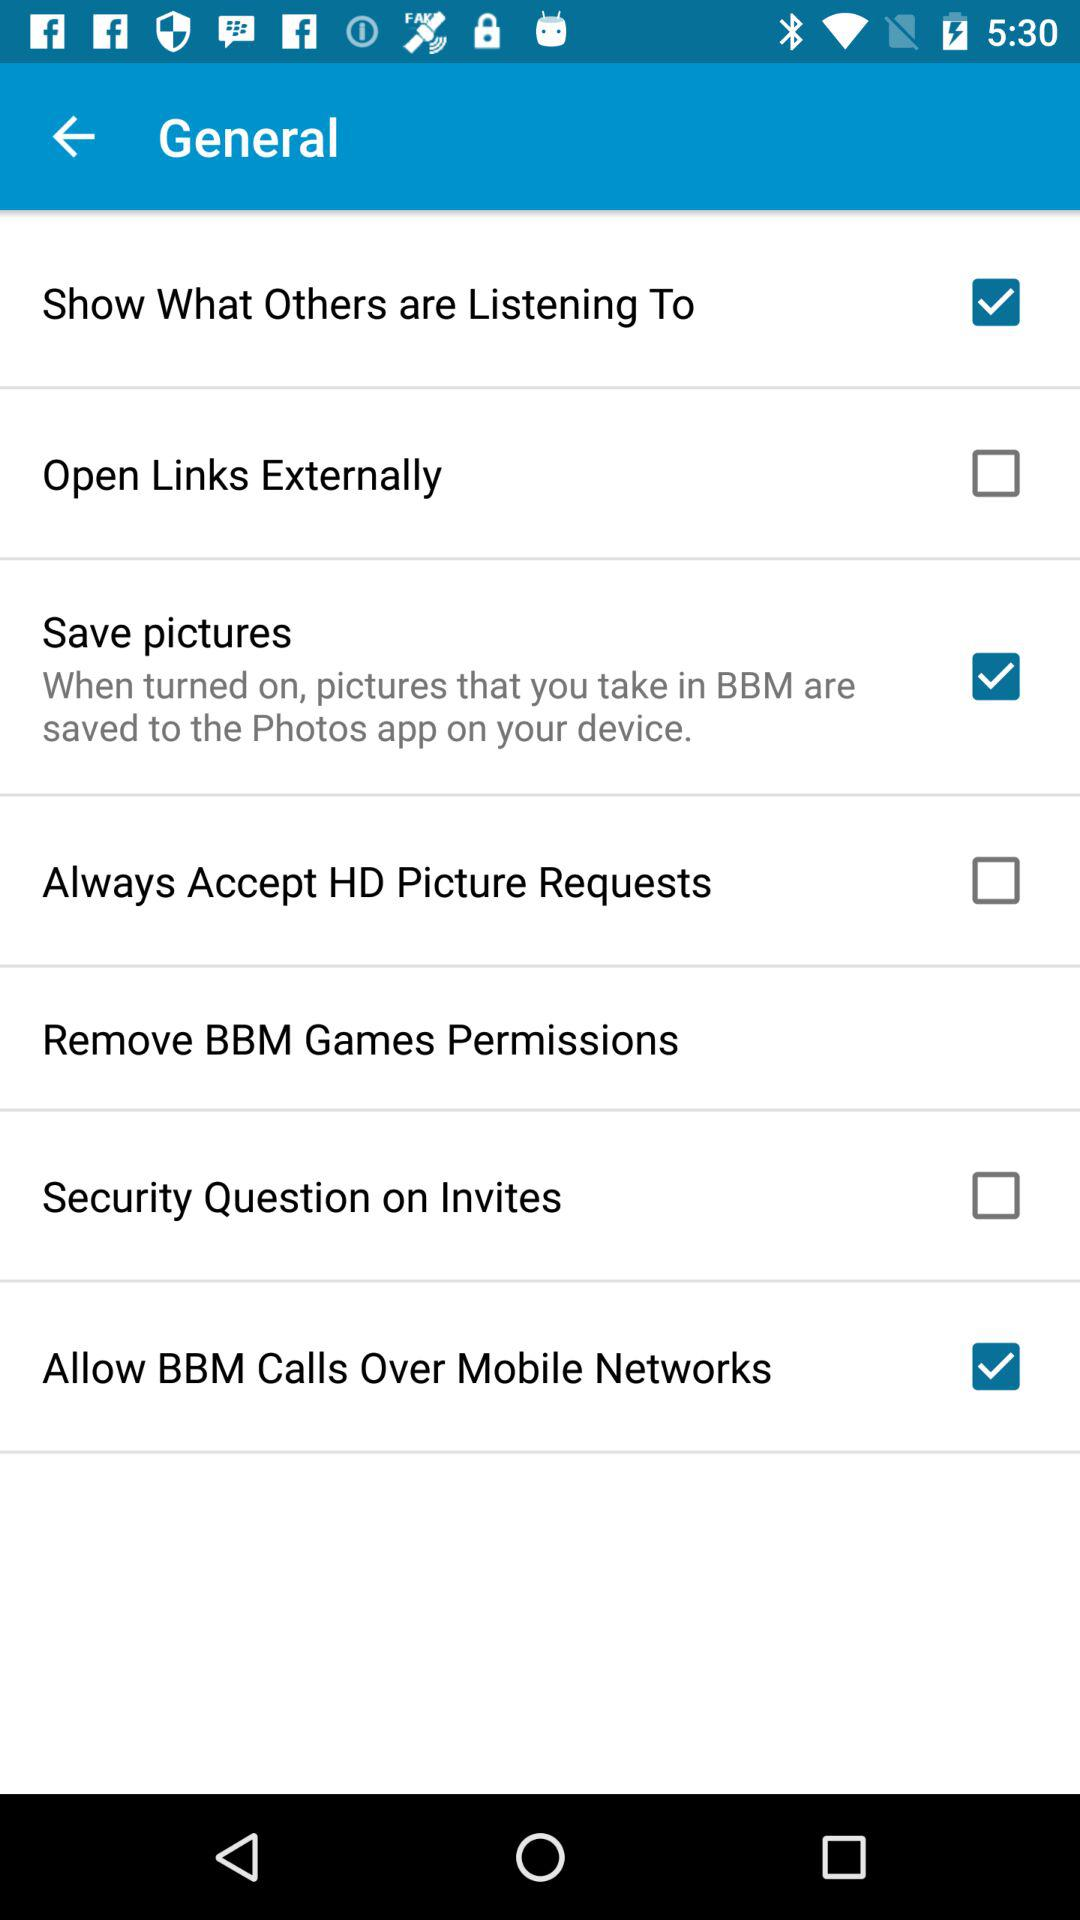Which option is selected? The selected options are "Show What Others are Listening To", "Save pictures" and "Allow BBM Calls Over Mobile Networks". 